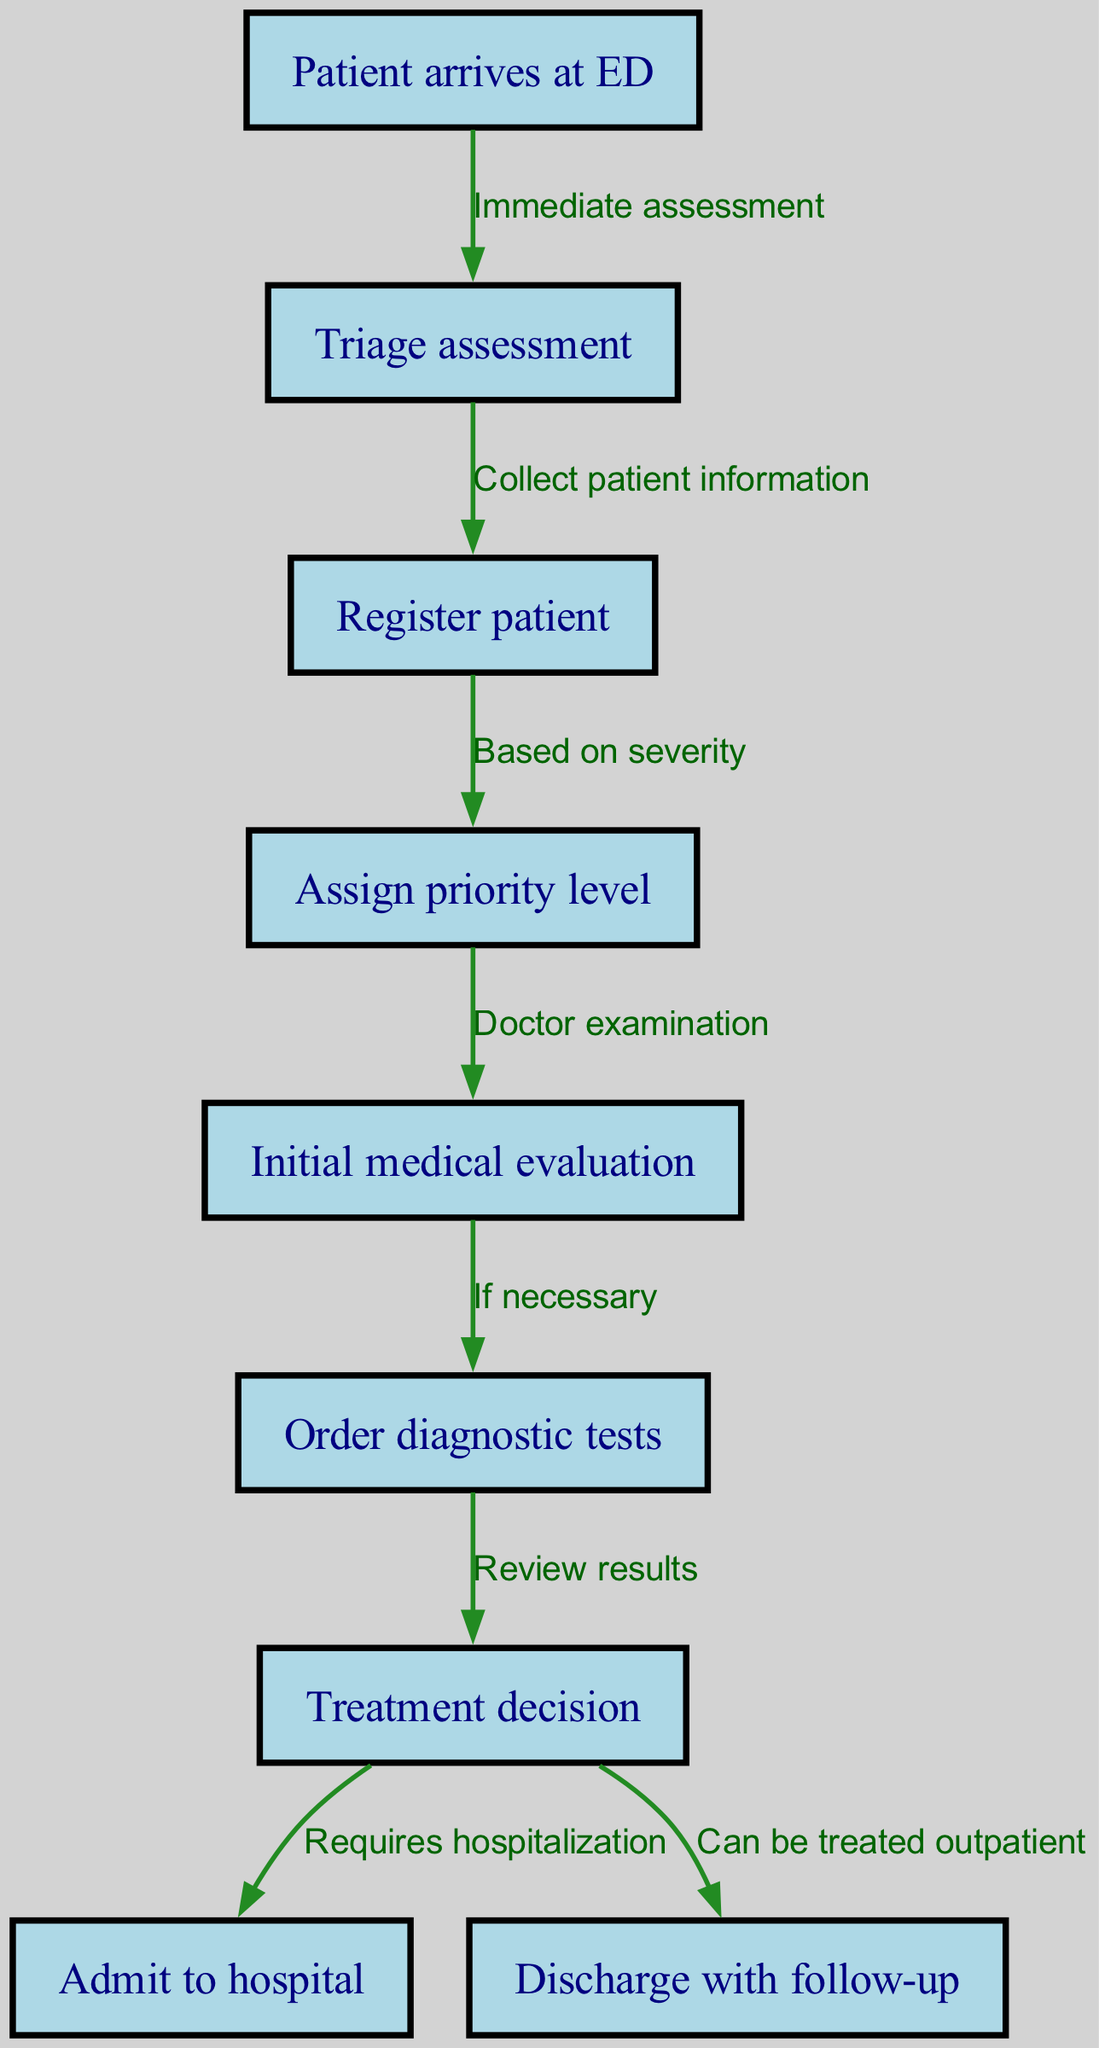What is the first step in the patient admission process? The diagram clearly indicates that the first step is when the "Patient arrives at ED." This is presented as the initial node in the pathway flow.
Answer: Patient arrives at ED How many edges are in the diagram? By counting the arrows that connect different nodes in the diagram, we can find that there are a total of eight edges connecting the nodes.
Answer: 8 What node follows "Triage assessment"? The flow of the diagram shows that the node labeled "Register patient" directly follows "Triage assessment," indicating the next step in the process.
Answer: Register patient What is the priority level assigned based on? The diagram indicates that the "Assign priority level" step is based on "severity," which is specified in the edge connecting these two nodes.
Answer: severity What happens if diagnostic tests are ordered? The diagram outlines two possible paths following the "Order diagnostic tests" step. It leads to a "Treatment decision," which can then either result in being "Admit to hospital" or "Discharge with follow-up."
Answer: Requires hospitalization or Can be treated outpatient What step does the patient go to after the "Initial medical evaluation"? According to the diagram, the "Initial medical evaluation" is followed by the "Order diagnostic tests" step if deemed necessary, illustrating the flow of the clinical pathway.
Answer: Order diagnostic tests How many nodes are there in the diagram? By counting all the distinct steps or actions present in the diagram, it can be concluded that there are a total of nine nodes listed.
Answer: 9 What is the action taken after registering the patient? The diagram specifies that after the "Register patient" step, the next action taken is to "Assign priority level," indicating the progression in the admission process.
Answer: Assign priority level 